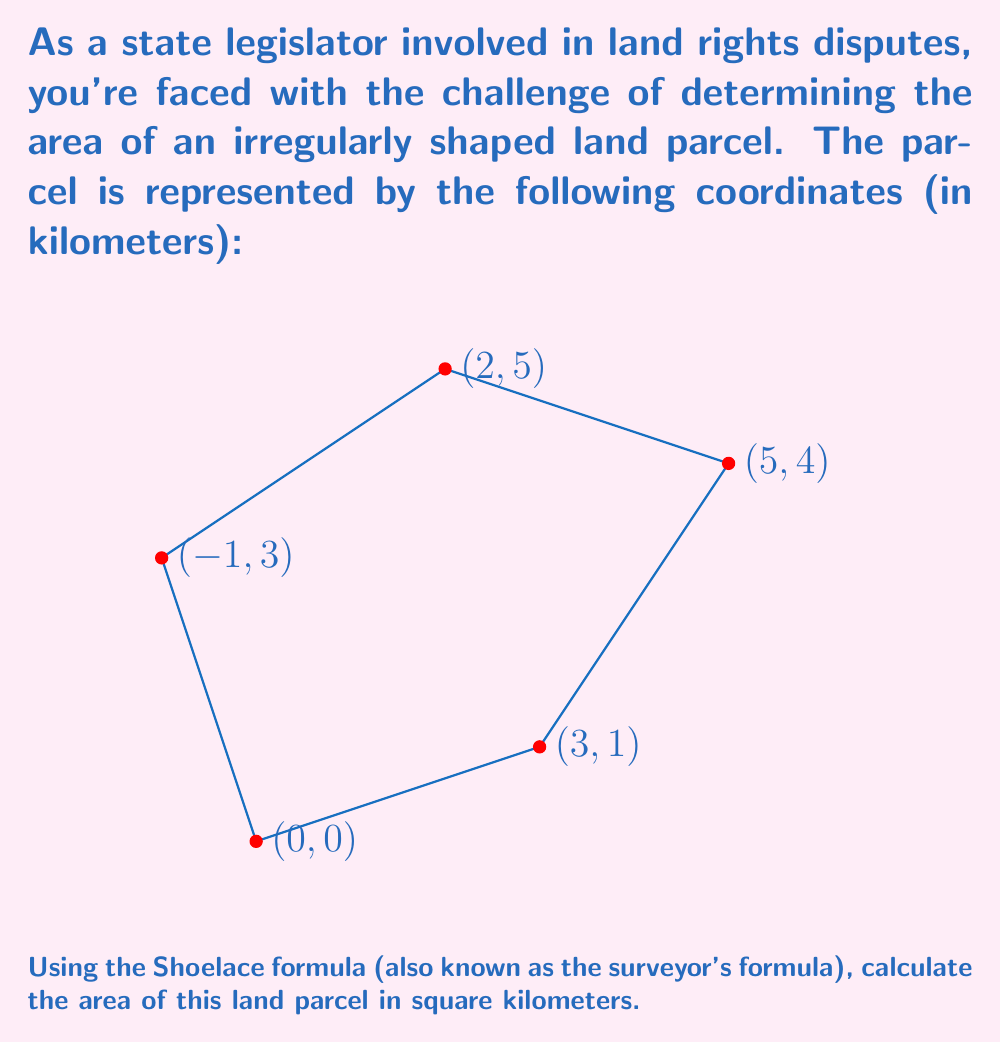Help me with this question. The Shoelace formula, or surveyor's formula, is a method for calculating the area of a polygon given the coordinates of its vertices. The formula is:

$$ A = \frac{1}{2}\left|\sum_{i=1}^{n-1} (x_iy_{i+1} - x_{i+1}y_i) + (x_ny_1 - x_1y_n)\right| $$

Where $(x_i, y_i)$ are the coordinates of the $i$-th vertex.

Let's apply this formula to our polygon:

1) First, let's list our coordinates in order:
   $(0,0)$, $(3,1)$, $(5,4)$, $(2,5)$, $(-1,3)$

2) Now, let's calculate each term in the sum:
   $(0 \cdot 1) - (3 \cdot 0) = 0$
   $(3 \cdot 4) - (5 \cdot 1) = 7$
   $(5 \cdot 5) - (2 \cdot 4) = 17$
   $(2 \cdot 3) - (-1 \cdot 5) = 11$
   $(-1 \cdot 0) - (0 \cdot 3) = 0$

3) Sum these terms:
   $0 + 7 + 17 + 11 + 0 = 35$

4) Multiply by $\frac{1}{2}$:
   $\frac{1}{2} \cdot 35 = 17.5$

Therefore, the area of the land parcel is 17.5 square kilometers.
Answer: 17.5 km² 